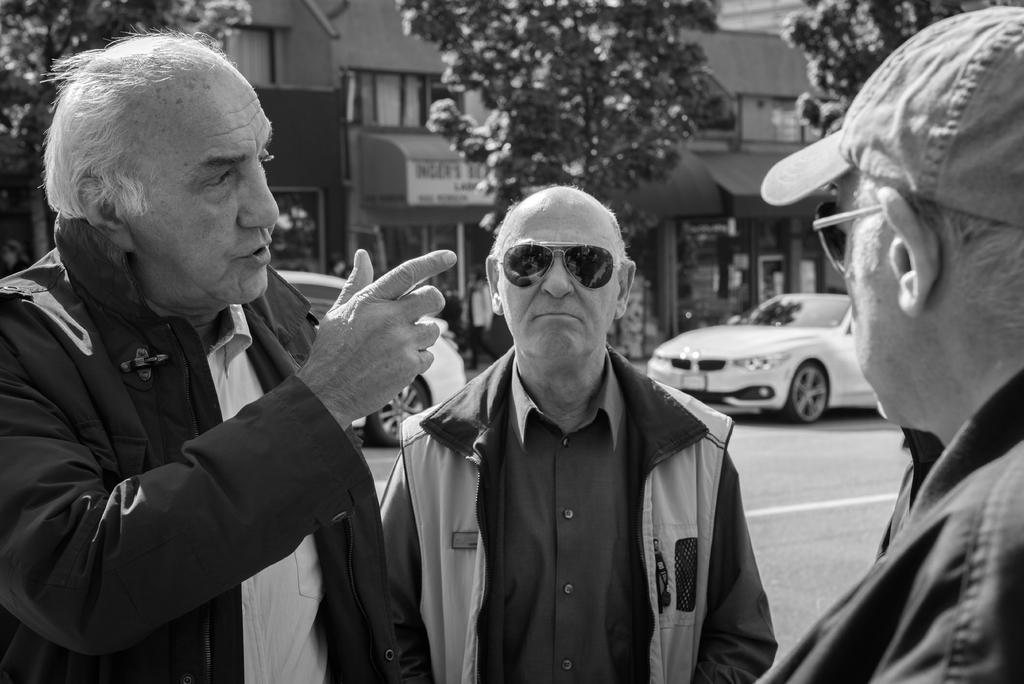How many men are wearing goggles in the image? There are two men wearing goggles in the image. What is one of the men doing in the image? There is a man talking in the image. What can be seen on the road in the image? Cars are visible on the road in the image. What type of vegetation is present in the image? There are trees in the image. What is the name of the place or establishment in the image? There is a name board in the image, which may indicate the name of the place or establishment. What type of structures can be seen in the background of the image? Buildings are present in the background of the image. What type of window treatment is visible in the background of the image? Windows with curtains are visible in the background of the image. How many clocks are hanging on the trees in the image? There are no clocks hanging on the trees in the image. What type of worm can be seen crawling on the name board in the image? There are no worms present in the image, let alone on the name board. 